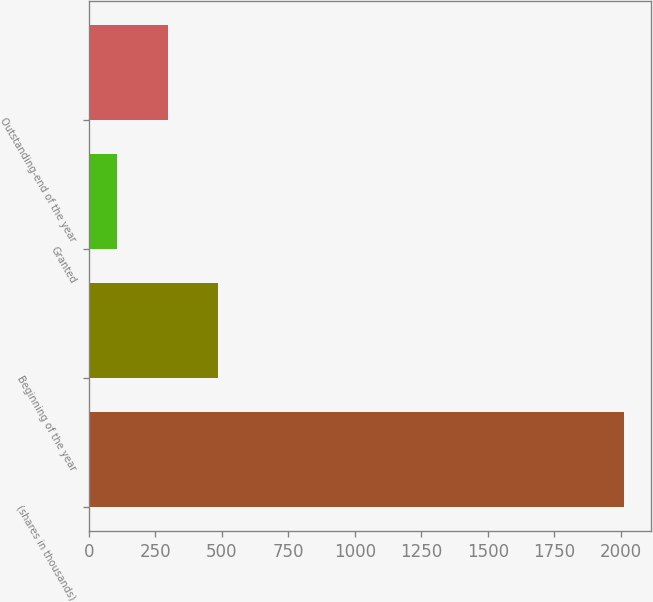Convert chart. <chart><loc_0><loc_0><loc_500><loc_500><bar_chart><fcel>(shares in thousands)<fcel>Beginning of the year<fcel>Granted<fcel>Outstanding-end of the year<nl><fcel>2014<fcel>486.8<fcel>105<fcel>295.9<nl></chart> 